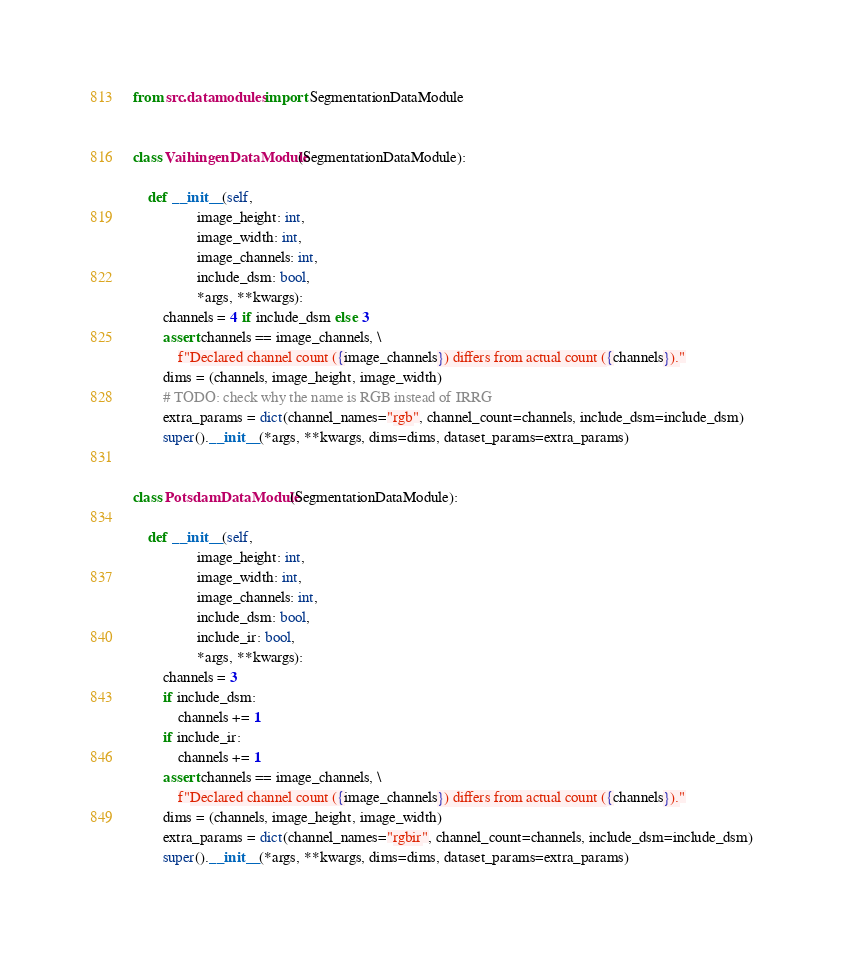Convert code to text. <code><loc_0><loc_0><loc_500><loc_500><_Python_>from src.datamodules import SegmentationDataModule


class VaihingenDataModule(SegmentationDataModule):

    def __init__(self,
                 image_height: int,
                 image_width: int,
                 image_channels: int,
                 include_dsm: bool,
                 *args, **kwargs):
        channels = 4 if include_dsm else 3
        assert channels == image_channels, \
            f"Declared channel count ({image_channels}) differs from actual count ({channels})."
        dims = (channels, image_height, image_width)
        # TODO: check why the name is RGB instead of IRRG
        extra_params = dict(channel_names="rgb", channel_count=channels, include_dsm=include_dsm)
        super().__init__(*args, **kwargs, dims=dims, dataset_params=extra_params)


class PotsdamDataModule(SegmentationDataModule):

    def __init__(self,
                 image_height: int,
                 image_width: int,
                 image_channels: int,
                 include_dsm: bool,
                 include_ir: bool,
                 *args, **kwargs):
        channels = 3
        if include_dsm:
            channels += 1
        if include_ir:
            channels += 1
        assert channels == image_channels, \
            f"Declared channel count ({image_channels}) differs from actual count ({channels})."
        dims = (channels, image_height, image_width)
        extra_params = dict(channel_names="rgbir", channel_count=channels, include_dsm=include_dsm)
        super().__init__(*args, **kwargs, dims=dims, dataset_params=extra_params)
</code> 